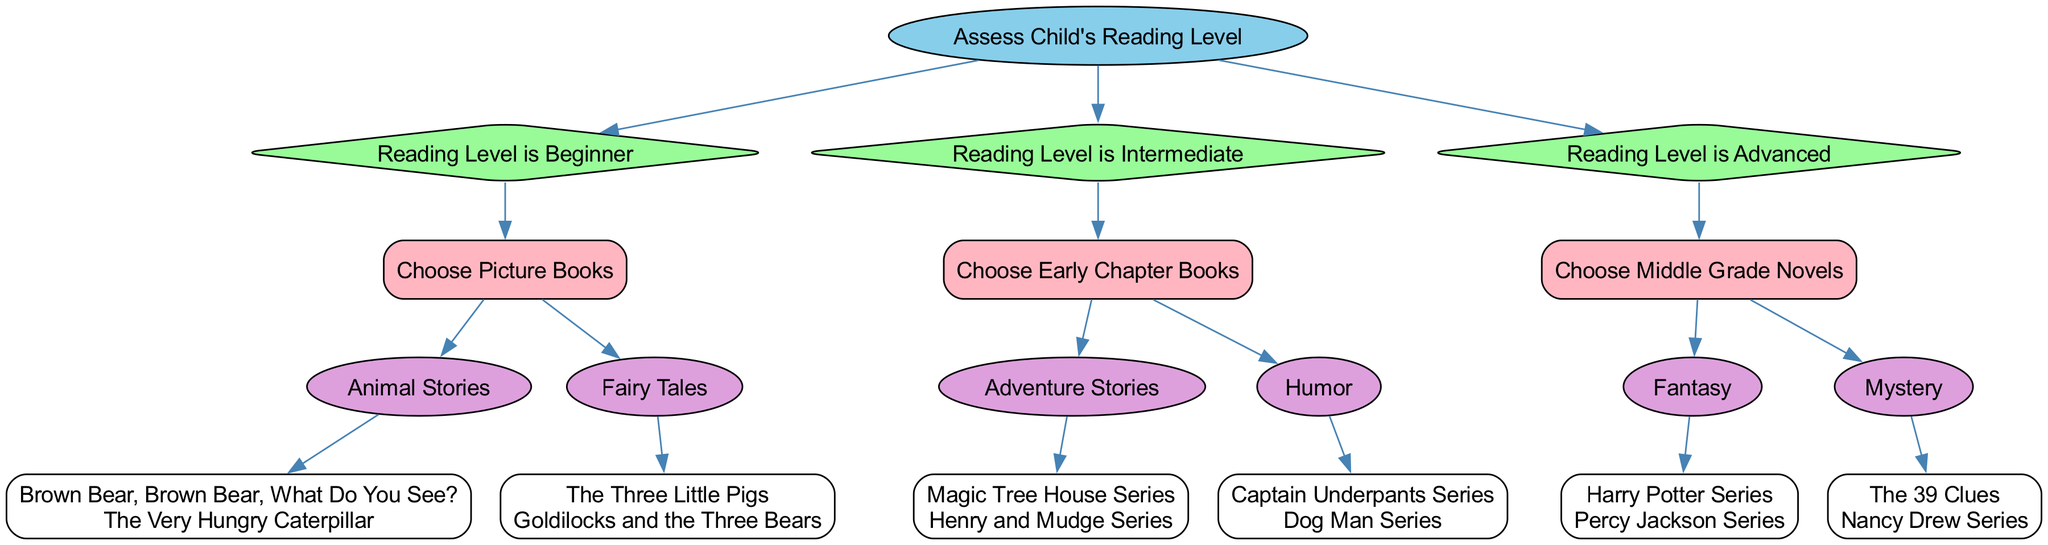What is the root node of the decision tree? The root node is identified from the top of the diagram and represents the starting point of the tree's assessments. In this case, it is "Assess Child's Reading Level".
Answer: Assess Child's Reading Level How many conditions are there in the decision tree? The decision tree has three main conditions, each representing a different reading level: Beginner, Intermediate, and Advanced. This can be counted by looking at the branches directly connected to the root.
Answer: 3 What genre is recommended for a child with a beginner reading level? The diagram shows two genres under the beginner reading level: Animal Stories and Fairy Tales, which can be identified from the first set of branches in the tree.
Answer: Animal Stories, Fairy Tales For an Intermediate reading level, what option is the child directed to choose? From the diagram, when the condition is Intermediate, the option provided is to "Choose Early Chapter Books." This can be found by following the correct branch from the Intermediate condition.
Answer: Choose Early Chapter Books How many genres are listed under the Advanced reading level option? Under the Advanced reading level, there are two genres presented: Fantasy and Mystery. This can be determined by reviewing the sub-choices available under that condition.
Answer: 2 What are the examples provided for the Fantasy genre? The examples can be found directly listed under the sub-choice for the Fantasy genre in the Advanced reading level: "Harry Potter Series" and "Percy Jackson Series."
Answer: Harry Potter Series, Percy Jackson Series Which decision tree condition corresponds to the option "Choose Picture Books"? The option "Choose Picture Books" is associated with the Beginner reading level condition. Following the tree's structure, it's the only choice available under that condition.
Answer: Beginner What is the relationship between 'Humor' and 'Intermediate'? The 'Humor' genre is a sub-choice that falls under the option "Choose Early Chapter Books," which is specifically for children with an Intermediate reading level, establishing a direct relationship between them in the decision tree.
Answer: Sub-choice of Early Chapter Books for Intermediate How many examples are listed under the Humor genre? In the diagram, the Humor genre provides two examples: "Captain Underpants Series" and "Dog Man Series," which can be counted directly from the examples listed under that genre.
Answer: 2 